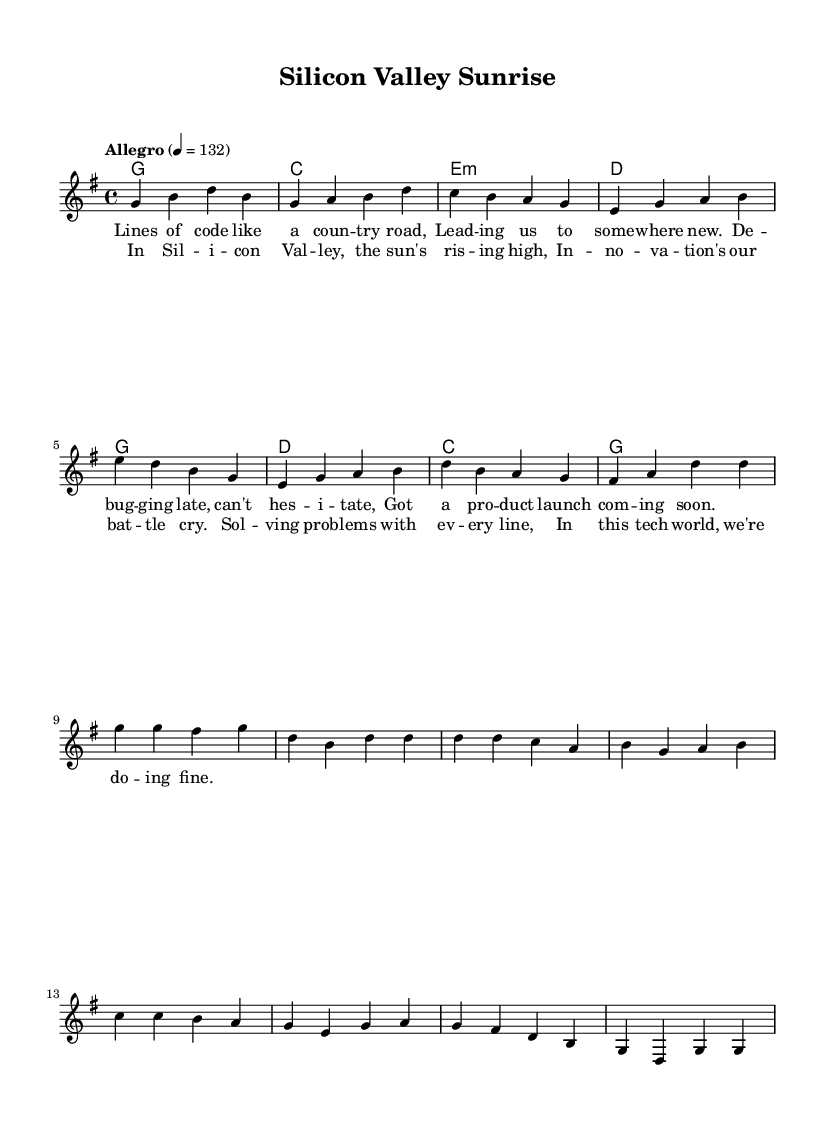What is the key signature of this music? The key signature is indicated as one sharp in the notation, which corresponds to G major.
Answer: G major What is the time signature of this music? The time signature is located at the beginning of the staff, which is 4/4. This means there are four beats per measure, with each beat represented by a quarter note.
Answer: 4/4 What is the tempo of this piece? The tempo is noted above the staff, indicating "Allegro" at a speed of 132 beats per minute. This suggests a lively and fast-paced style typical in upbeat country rock.
Answer: 132 How many measures are in the verse? The verse section contains eight measures, as indicated in the melody line where each group of notes corresponds to one measure.
Answer: Eight measures What chords are used in the chorus? The chords outlined for the chorus are G, D, C, and G. This can be deduced from the chord symbols aligned above the melody in the specified chorus section.
Answer: G, D, C, G What problem-solving theme is expressed in the lyrics? The lyrics reference debugging and product launches, suggesting a focus on overcoming challenges through innovation and tech development. This reflects the overall theme present in country rock music.
Answer: Problem-solving and innovation What is the overall mood of this song? The overall mood appears upbeat and celebratory, as indicated by both the tempo marking and the positive lyrics about innovation and collective efforts in technology.
Answer: Upbeat and celebratory 